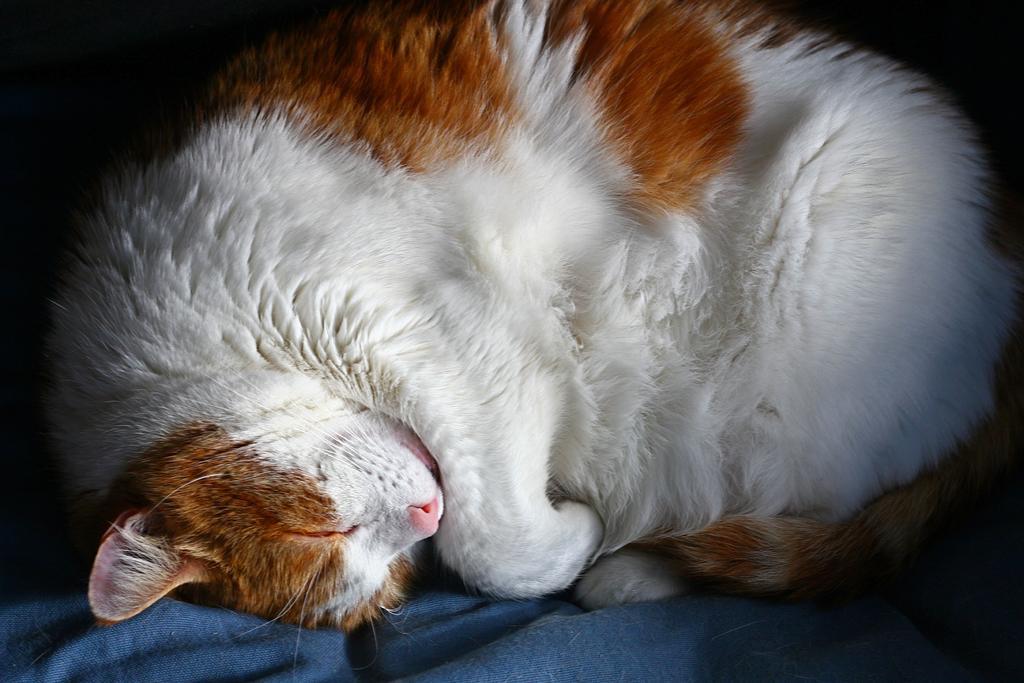How would you summarize this image in a sentence or two? In this image, we can see a white and brown color cat sleeping. 